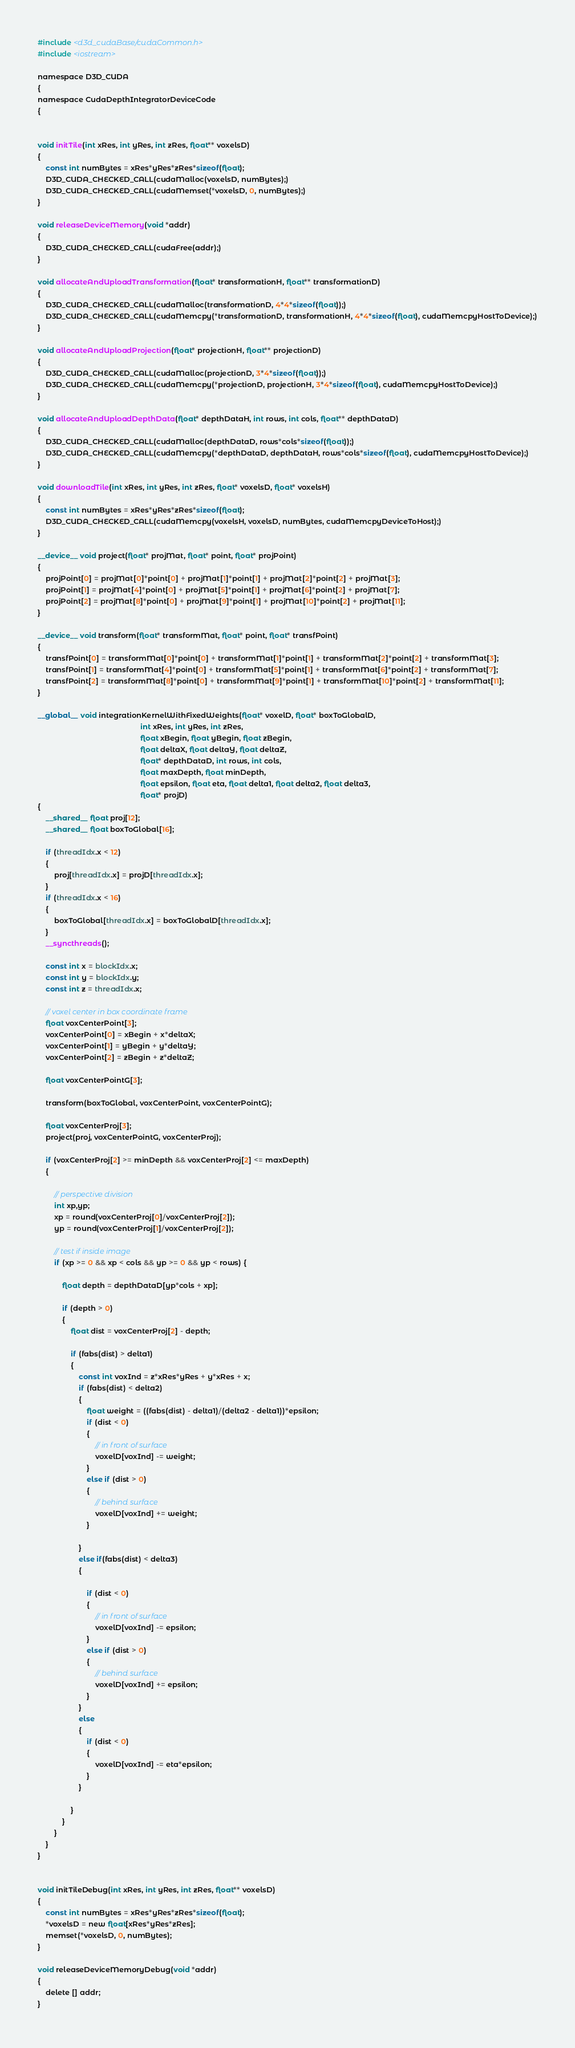<code> <loc_0><loc_0><loc_500><loc_500><_Cuda_>#include <d3d_cudaBase/cudaCommon.h>
#include <iostream>

namespace D3D_CUDA
{
namespace CudaDepthIntegratorDeviceCode
{


void initTile(int xRes, int yRes, int zRes, float** voxelsD)
{
    const int numBytes = xRes*yRes*zRes*sizeof(float);
    D3D_CUDA_CHECKED_CALL(cudaMalloc(voxelsD, numBytes);)
    D3D_CUDA_CHECKED_CALL(cudaMemset(*voxelsD, 0, numBytes);)
}

void releaseDeviceMemory(void *addr)
{
    D3D_CUDA_CHECKED_CALL(cudaFree(addr);)
}

void allocateAndUploadTransformation(float* transformationH, float** transformationD)
{
    D3D_CUDA_CHECKED_CALL(cudaMalloc(transformationD, 4*4*sizeof(float));)
    D3D_CUDA_CHECKED_CALL(cudaMemcpy(*transformationD, transformationH, 4*4*sizeof(float), cudaMemcpyHostToDevice);)
}

void allocateAndUploadProjection(float* projectionH, float** projectionD)
{
    D3D_CUDA_CHECKED_CALL(cudaMalloc(projectionD, 3*4*sizeof(float));)
    D3D_CUDA_CHECKED_CALL(cudaMemcpy(*projectionD, projectionH, 3*4*sizeof(float), cudaMemcpyHostToDevice);)
}

void allocateAndUploadDepthData(float* depthDataH, int rows, int cols, float** depthDataD)
{
    D3D_CUDA_CHECKED_CALL(cudaMalloc(depthDataD, rows*cols*sizeof(float));)
    D3D_CUDA_CHECKED_CALL(cudaMemcpy(*depthDataD, depthDataH, rows*cols*sizeof(float), cudaMemcpyHostToDevice);)
}

void downloadTile(int xRes, int yRes, int zRes, float* voxelsD, float* voxelsH)
{
    const int numBytes = xRes*yRes*zRes*sizeof(float);
    D3D_CUDA_CHECKED_CALL(cudaMemcpy(voxelsH, voxelsD, numBytes, cudaMemcpyDeviceToHost);)
}

__device__ void project(float* projMat, float* point, float* projPoint)
{
    projPoint[0] = projMat[0]*point[0] + projMat[1]*point[1] + projMat[2]*point[2] + projMat[3];
    projPoint[1] = projMat[4]*point[0] + projMat[5]*point[1] + projMat[6]*point[2] + projMat[7];
    projPoint[2] = projMat[8]*point[0] + projMat[9]*point[1] + projMat[10]*point[2] + projMat[11];
}

__device__ void transform(float* transformMat, float* point, float* transfPoint)
{
    transfPoint[0] = transformMat[0]*point[0] + transformMat[1]*point[1] + transformMat[2]*point[2] + transformMat[3];
    transfPoint[1] = transformMat[4]*point[0] + transformMat[5]*point[1] + transformMat[6]*point[2] + transformMat[7];
    transfPoint[2] = transformMat[8]*point[0] + transformMat[9]*point[1] + transformMat[10]*point[2] + transformMat[11];
}

__global__ void integrationKernelWithFixedWeights(float* voxelD, float* boxToGlobalD,
                                                  int xRes, int yRes, int zRes,
                                                  float xBegin, float yBegin, float zBegin,
                                                  float deltaX, float deltaY, float deltaZ,
                                                  float* depthDataD, int rows, int cols,
                                                  float maxDepth, float minDepth,
                                                  float epsilon, float eta, float delta1, float delta2, float delta3,
                                                  float* projD)
{
    __shared__ float proj[12];
    __shared__ float boxToGlobal[16];

    if (threadIdx.x < 12)
    {
        proj[threadIdx.x] = projD[threadIdx.x];
    }
    if (threadIdx.x < 16)
    {
        boxToGlobal[threadIdx.x] = boxToGlobalD[threadIdx.x];
    }
    __syncthreads();

    const int x = blockIdx.x;
    const int y = blockIdx.y;
    const int z = threadIdx.x;

    // voxel center in box coordinate frame
    float voxCenterPoint[3];
    voxCenterPoint[0] = xBegin + x*deltaX;
    voxCenterPoint[1] = yBegin + y*deltaY;
    voxCenterPoint[2] = zBegin + z*deltaZ;

    float voxCenterPointG[3];

    transform(boxToGlobal, voxCenterPoint, voxCenterPointG);

    float voxCenterProj[3];
    project(proj, voxCenterPointG, voxCenterProj);

    if (voxCenterProj[2] >= minDepth && voxCenterProj[2] <= maxDepth)
    {

        // perspective division
        int xp,yp;
        xp = round(voxCenterProj[0]/voxCenterProj[2]);
        yp = round(voxCenterProj[1]/voxCenterProj[2]);

        // test if inside image
        if (xp >= 0 && xp < cols && yp >= 0 && yp < rows) {

            float depth = depthDataD[yp*cols + xp];

            if (depth > 0)
            {
                float dist = voxCenterProj[2] - depth;

                if (fabs(dist) > delta1)
                {
                    const int voxInd = z*xRes*yRes + y*xRes + x;
                    if (fabs(dist) < delta2)
                    {
                        float weight = ((fabs(dist) - delta1)/(delta2 - delta1))*epsilon;
                        if (dist < 0)
                        {
                            // in front of surface
                            voxelD[voxInd] -= weight;
                        }
                        else if (dist > 0)
                        {
                            // behind surface
                            voxelD[voxInd] += weight;
                        }

                    }
                    else if(fabs(dist) < delta3)
                    {

                        if (dist < 0)
                        {
                            // in front of surface
                            voxelD[voxInd] -= epsilon;
                        }
                        else if (dist > 0)
                        {
                            // behind surface
                            voxelD[voxInd] += epsilon;
                        }
                    }
                    else
                    {
                        if (dist < 0)
                        {
                            voxelD[voxInd] -= eta*epsilon;
                        }
                    }

                }
            }
        }
    }
}


void initTileDebug(int xRes, int yRes, int zRes, float** voxelsD)
{
    const int numBytes = xRes*yRes*zRes*sizeof(float);
    *voxelsD = new float[xRes*yRes*zRes];
    memset(*voxelsD, 0, numBytes);
}

void releaseDeviceMemoryDebug(void *addr)
{
    delete [] addr;
}
</code> 